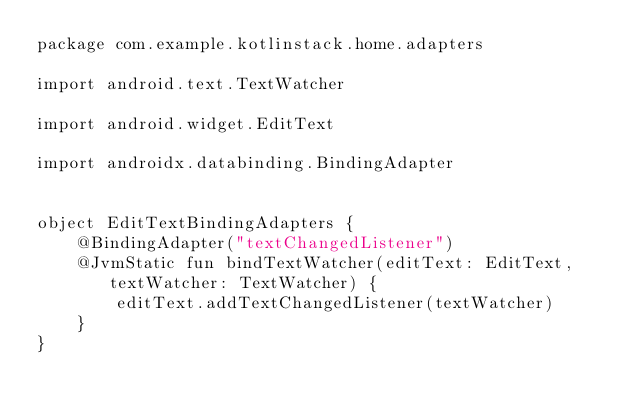<code> <loc_0><loc_0><loc_500><loc_500><_Kotlin_>package com.example.kotlinstack.home.adapters

import android.text.TextWatcher

import android.widget.EditText

import androidx.databinding.BindingAdapter


object EditTextBindingAdapters {
    @BindingAdapter("textChangedListener")
    @JvmStatic fun bindTextWatcher(editText: EditText, textWatcher: TextWatcher) {
        editText.addTextChangedListener(textWatcher)
    }
}
</code> 